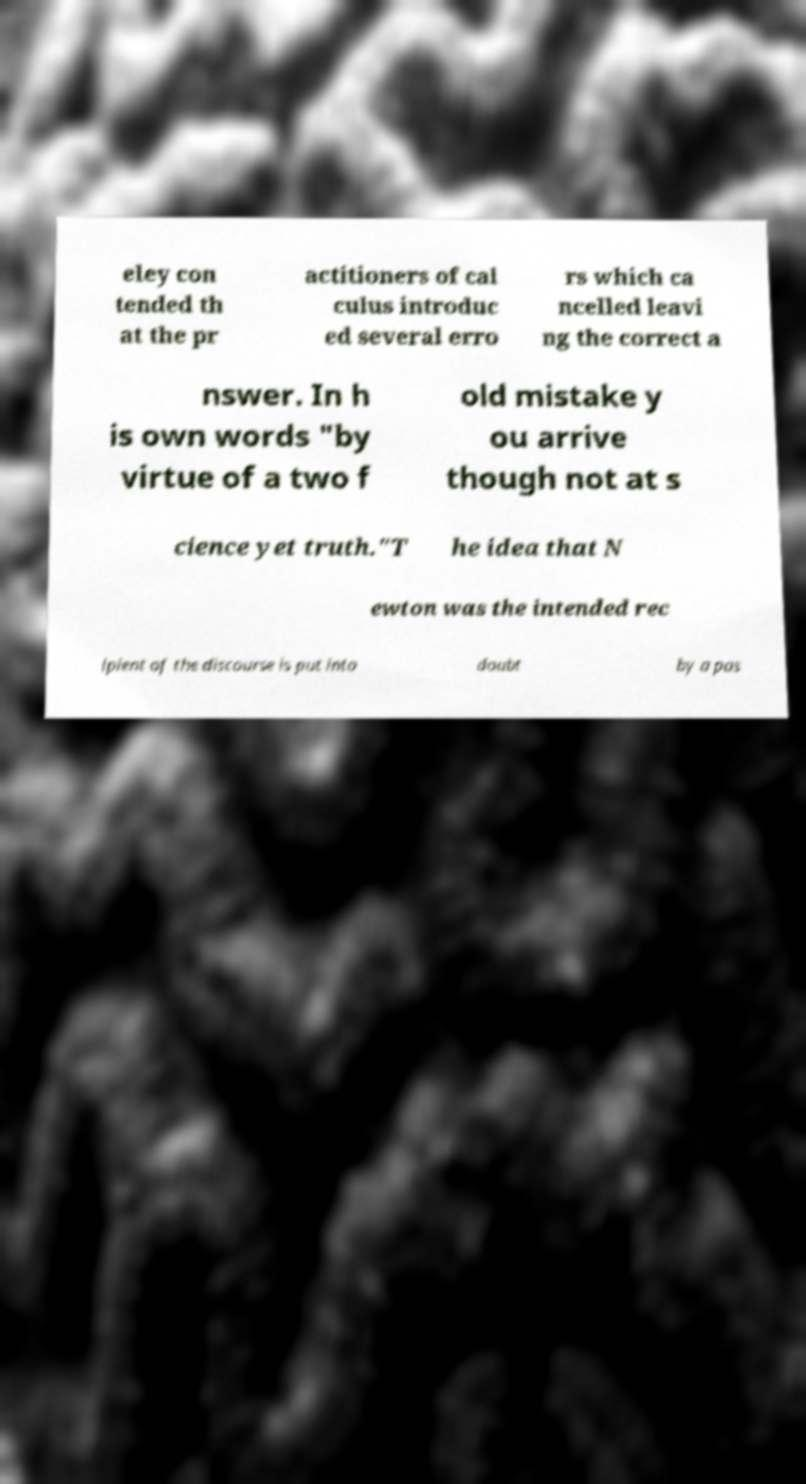Please read and relay the text visible in this image. What does it say? eley con tended th at the pr actitioners of cal culus introduc ed several erro rs which ca ncelled leavi ng the correct a nswer. In h is own words "by virtue of a two f old mistake y ou arrive though not at s cience yet truth."T he idea that N ewton was the intended rec ipient of the discourse is put into doubt by a pas 